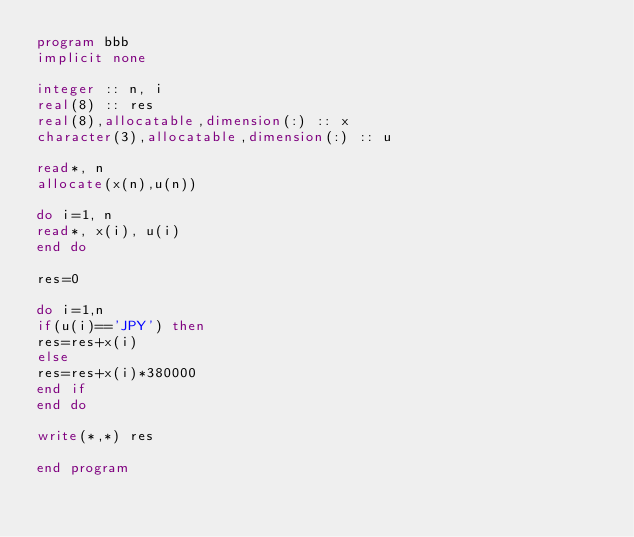Convert code to text. <code><loc_0><loc_0><loc_500><loc_500><_FORTRAN_>program bbb
implicit none

integer :: n, i
real(8) :: res
real(8),allocatable,dimension(:) :: x
character(3),allocatable,dimension(:) :: u

read*, n
allocate(x(n),u(n))

do i=1, n
read*, x(i), u(i)
end do

res=0

do i=1,n
if(u(i)=='JPY') then
res=res+x(i)
else
res=res+x(i)*380000
end if
end do

write(*,*) res

end program</code> 